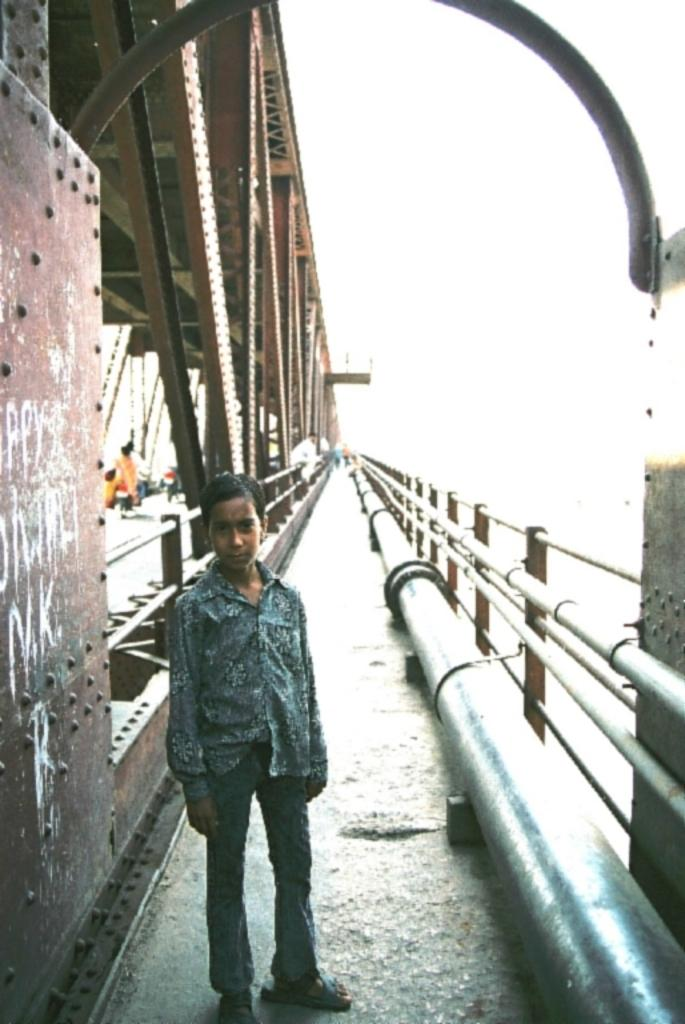What is the person in the image doing? The person is standing on the bridge. What else can be seen on the bridge in the image? Motor vehicles are present on the bridge. What type of material is used for the grills in the image? Iron grills are visible in the image. What else is present in the image besides the bridge and the person? Pipelines are present in the image. What is visible in the background of the image? The sky is visible in the image. What type of plants can be seen growing on the person's scarf in the image? There is no scarf or plants present in the image. 